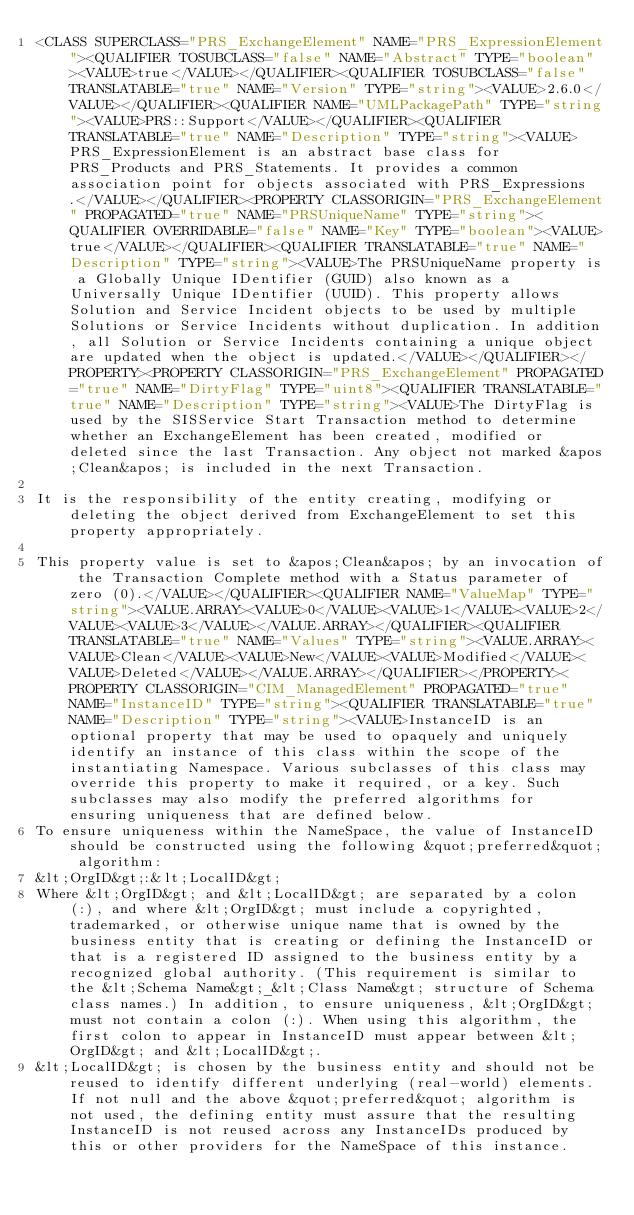Convert code to text. <code><loc_0><loc_0><loc_500><loc_500><_XML_><CLASS SUPERCLASS="PRS_ExchangeElement" NAME="PRS_ExpressionElement"><QUALIFIER TOSUBCLASS="false" NAME="Abstract" TYPE="boolean"><VALUE>true</VALUE></QUALIFIER><QUALIFIER TOSUBCLASS="false" TRANSLATABLE="true" NAME="Version" TYPE="string"><VALUE>2.6.0</VALUE></QUALIFIER><QUALIFIER NAME="UMLPackagePath" TYPE="string"><VALUE>PRS::Support</VALUE></QUALIFIER><QUALIFIER TRANSLATABLE="true" NAME="Description" TYPE="string"><VALUE>PRS_ExpressionElement is an abstract base class for PRS_Products and PRS_Statements. It provides a common association point for objects associated with PRS_Expressions.</VALUE></QUALIFIER><PROPERTY CLASSORIGIN="PRS_ExchangeElement" PROPAGATED="true" NAME="PRSUniqueName" TYPE="string"><QUALIFIER OVERRIDABLE="false" NAME="Key" TYPE="boolean"><VALUE>true</VALUE></QUALIFIER><QUALIFIER TRANSLATABLE="true" NAME="Description" TYPE="string"><VALUE>The PRSUniqueName property is a Globally Unique IDentifier (GUID) also known as a Universally Unique IDentifier (UUID). This property allows Solution and Service Incident objects to be used by multiple Solutions or Service Incidents without duplication. In addition, all Solution or Service Incidents containing a unique object are updated when the object is updated.</VALUE></QUALIFIER></PROPERTY><PROPERTY CLASSORIGIN="PRS_ExchangeElement" PROPAGATED="true" NAME="DirtyFlag" TYPE="uint8"><QUALIFIER TRANSLATABLE="true" NAME="Description" TYPE="string"><VALUE>The DirtyFlag is used by the SISService Start Transaction method to determine whether an ExchangeElement has been created, modified or deleted since the last Transaction. Any object not marked &apos;Clean&apos; is included in the next Transaction. 

It is the responsibility of the entity creating, modifying or deleting the object derived from ExchangeElement to set this property appropriately. 

This property value is set to &apos;Clean&apos; by an invocation of the Transaction Complete method with a Status parameter of zero (0).</VALUE></QUALIFIER><QUALIFIER NAME="ValueMap" TYPE="string"><VALUE.ARRAY><VALUE>0</VALUE><VALUE>1</VALUE><VALUE>2</VALUE><VALUE>3</VALUE></VALUE.ARRAY></QUALIFIER><QUALIFIER TRANSLATABLE="true" NAME="Values" TYPE="string"><VALUE.ARRAY><VALUE>Clean</VALUE><VALUE>New</VALUE><VALUE>Modified</VALUE><VALUE>Deleted</VALUE></VALUE.ARRAY></QUALIFIER></PROPERTY><PROPERTY CLASSORIGIN="CIM_ManagedElement" PROPAGATED="true" NAME="InstanceID" TYPE="string"><QUALIFIER TRANSLATABLE="true" NAME="Description" TYPE="string"><VALUE>InstanceID is an optional property that may be used to opaquely and uniquely identify an instance of this class within the scope of the instantiating Namespace. Various subclasses of this class may override this property to make it required, or a key. Such subclasses may also modify the preferred algorithms for ensuring uniqueness that are defined below.
To ensure uniqueness within the NameSpace, the value of InstanceID should be constructed using the following &quot;preferred&quot; algorithm: 
&lt;OrgID&gt;:&lt;LocalID&gt; 
Where &lt;OrgID&gt; and &lt;LocalID&gt; are separated by a colon (:), and where &lt;OrgID&gt; must include a copyrighted, trademarked, or otherwise unique name that is owned by the business entity that is creating or defining the InstanceID or that is a registered ID assigned to the business entity by a recognized global authority. (This requirement is similar to the &lt;Schema Name&gt;_&lt;Class Name&gt; structure of Schema class names.) In addition, to ensure uniqueness, &lt;OrgID&gt; must not contain a colon (:). When using this algorithm, the first colon to appear in InstanceID must appear between &lt;OrgID&gt; and &lt;LocalID&gt;. 
&lt;LocalID&gt; is chosen by the business entity and should not be reused to identify different underlying (real-world) elements. If not null and the above &quot;preferred&quot; algorithm is not used, the defining entity must assure that the resulting InstanceID is not reused across any InstanceIDs produced by this or other providers for the NameSpace of this instance. </code> 